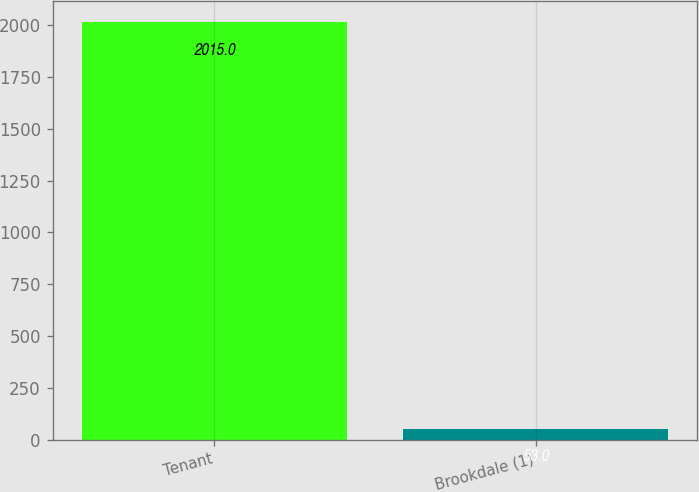Convert chart to OTSL. <chart><loc_0><loc_0><loc_500><loc_500><bar_chart><fcel>Tenant<fcel>Brookdale (1)<nl><fcel>2015<fcel>53<nl></chart> 